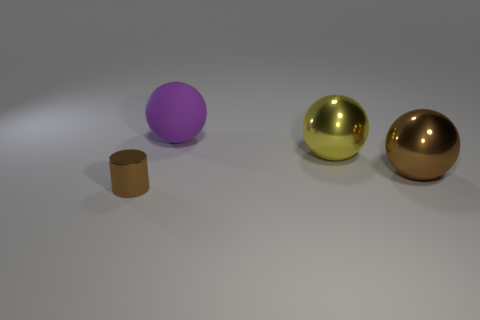What material is the purple object that is the same shape as the big brown shiny object?
Offer a very short reply. Rubber. Do the big purple matte thing and the shiny object that is behind the big brown object have the same shape?
Give a very brief answer. Yes. Are there any other things of the same color as the shiny cylinder?
Give a very brief answer. Yes. There is a object on the left side of the large purple sphere; does it have the same color as the large ball that is in front of the yellow ball?
Ensure brevity in your answer.  Yes. Is there a tiny purple cube?
Your response must be concise. No. Are there any large yellow spheres made of the same material as the brown cylinder?
Keep it short and to the point. Yes. Are there any other things that are the same material as the purple object?
Offer a very short reply. No. What is the color of the big matte object?
Make the answer very short. Purple. There is a metallic thing that is the same color as the cylinder; what is its shape?
Your response must be concise. Sphere. There is another metal thing that is the same size as the yellow object; what is its color?
Provide a short and direct response. Brown. 